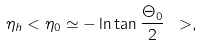<formula> <loc_0><loc_0><loc_500><loc_500>\eta _ { h } < \eta _ { 0 } \simeq - \ln \tan \frac { \Theta _ { 0 } } { 2 } \ > ,</formula> 